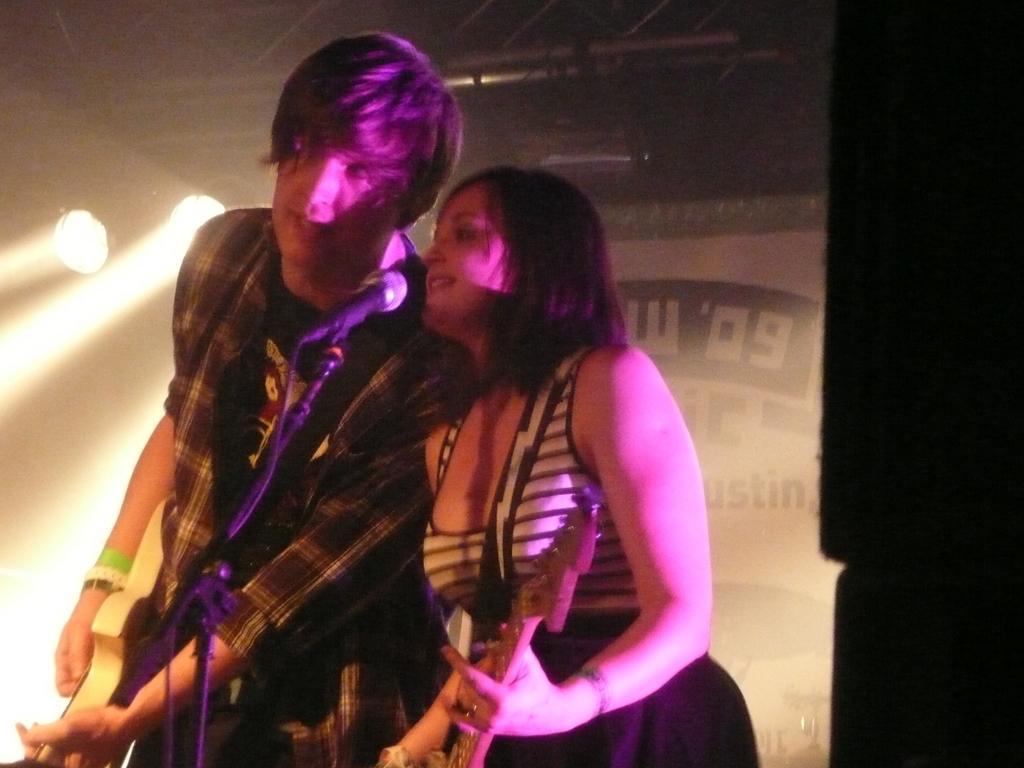Can you describe this image briefly? The picture is clicked in a musical concert where a guy and a lady is singing through a mic placed in front of them. In the background there are lights fitted to the roof and there are posters. 